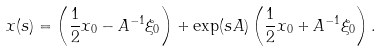<formula> <loc_0><loc_0><loc_500><loc_500>x ( s ) = \left ( \frac { 1 } { 2 } x _ { 0 } - A ^ { - 1 } \xi _ { 0 } \right ) + \exp ( s A ) \left ( \frac { 1 } { 2 } x _ { 0 } + A ^ { - 1 } \xi _ { 0 } \right ) .</formula> 